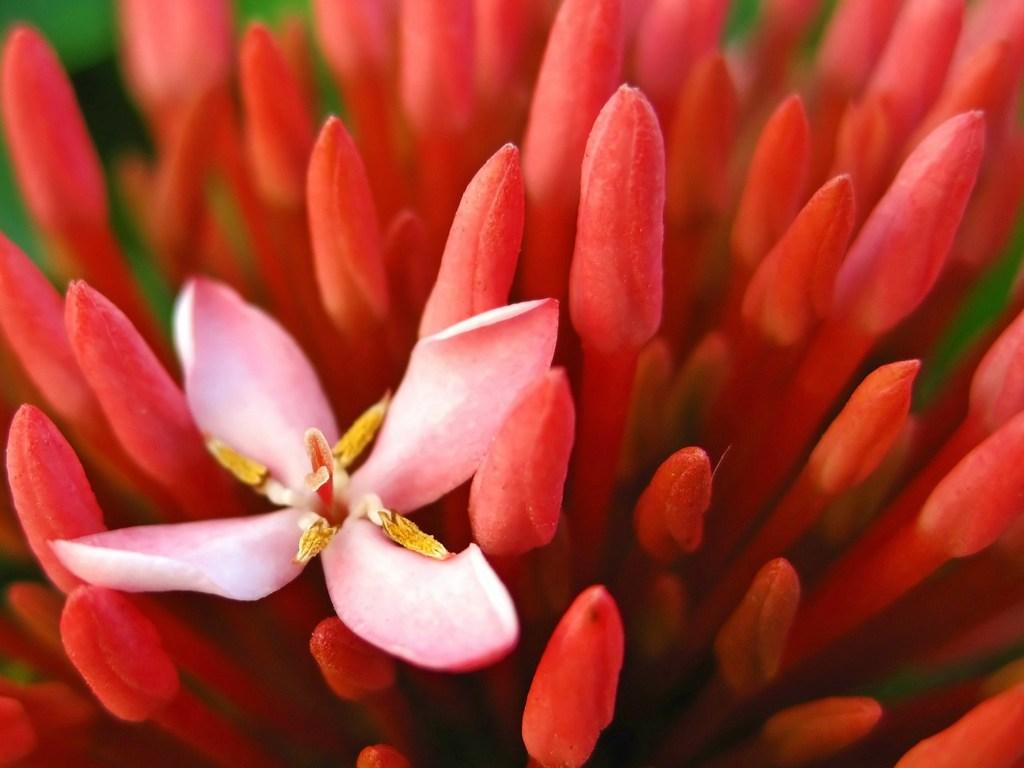What is the main subject of the image? There is a flower in the image. What time of day is the flower walking on the railway in the image? There is no mention of time of day, feet, or railway in the image; it only features a flower. 